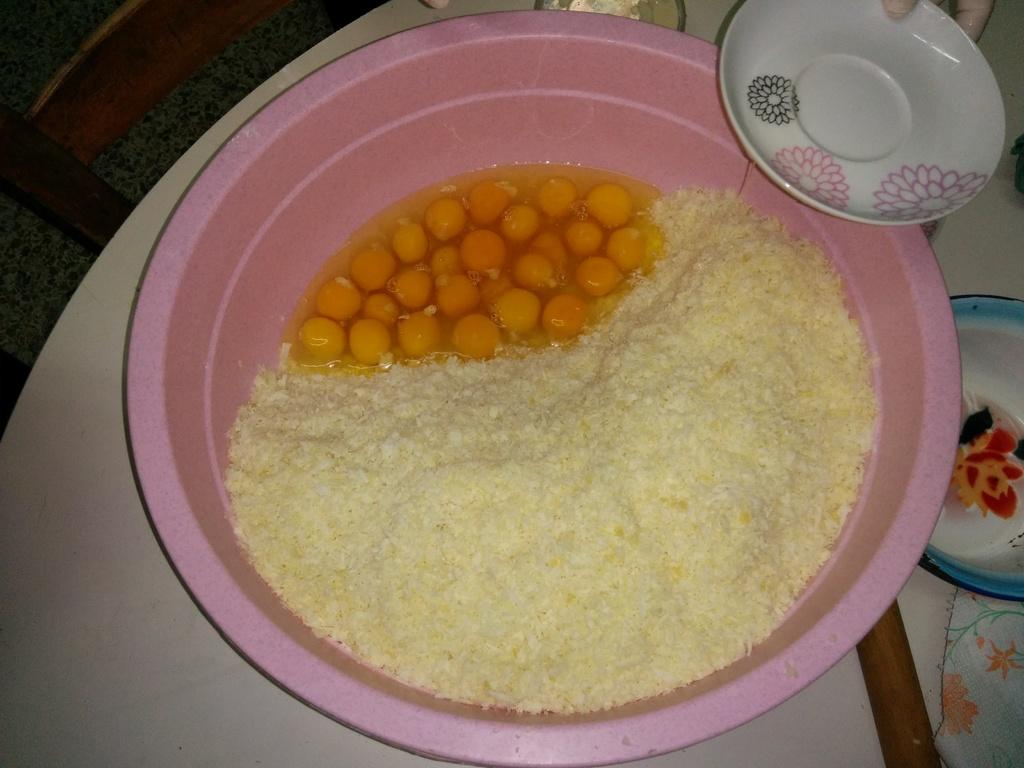What color is the bowl in the image? The bowl in the image is pink. What is inside the bowl? The bowl contains food. Is there any other dish visible in the image? Yes, there is a white color plate on the bowl. On what surface is the bowl placed? The bowl is placed on a white color table. What scientific experiment is being conducted on the rail in the image? There is no rail or scientific experiment present in the image. 